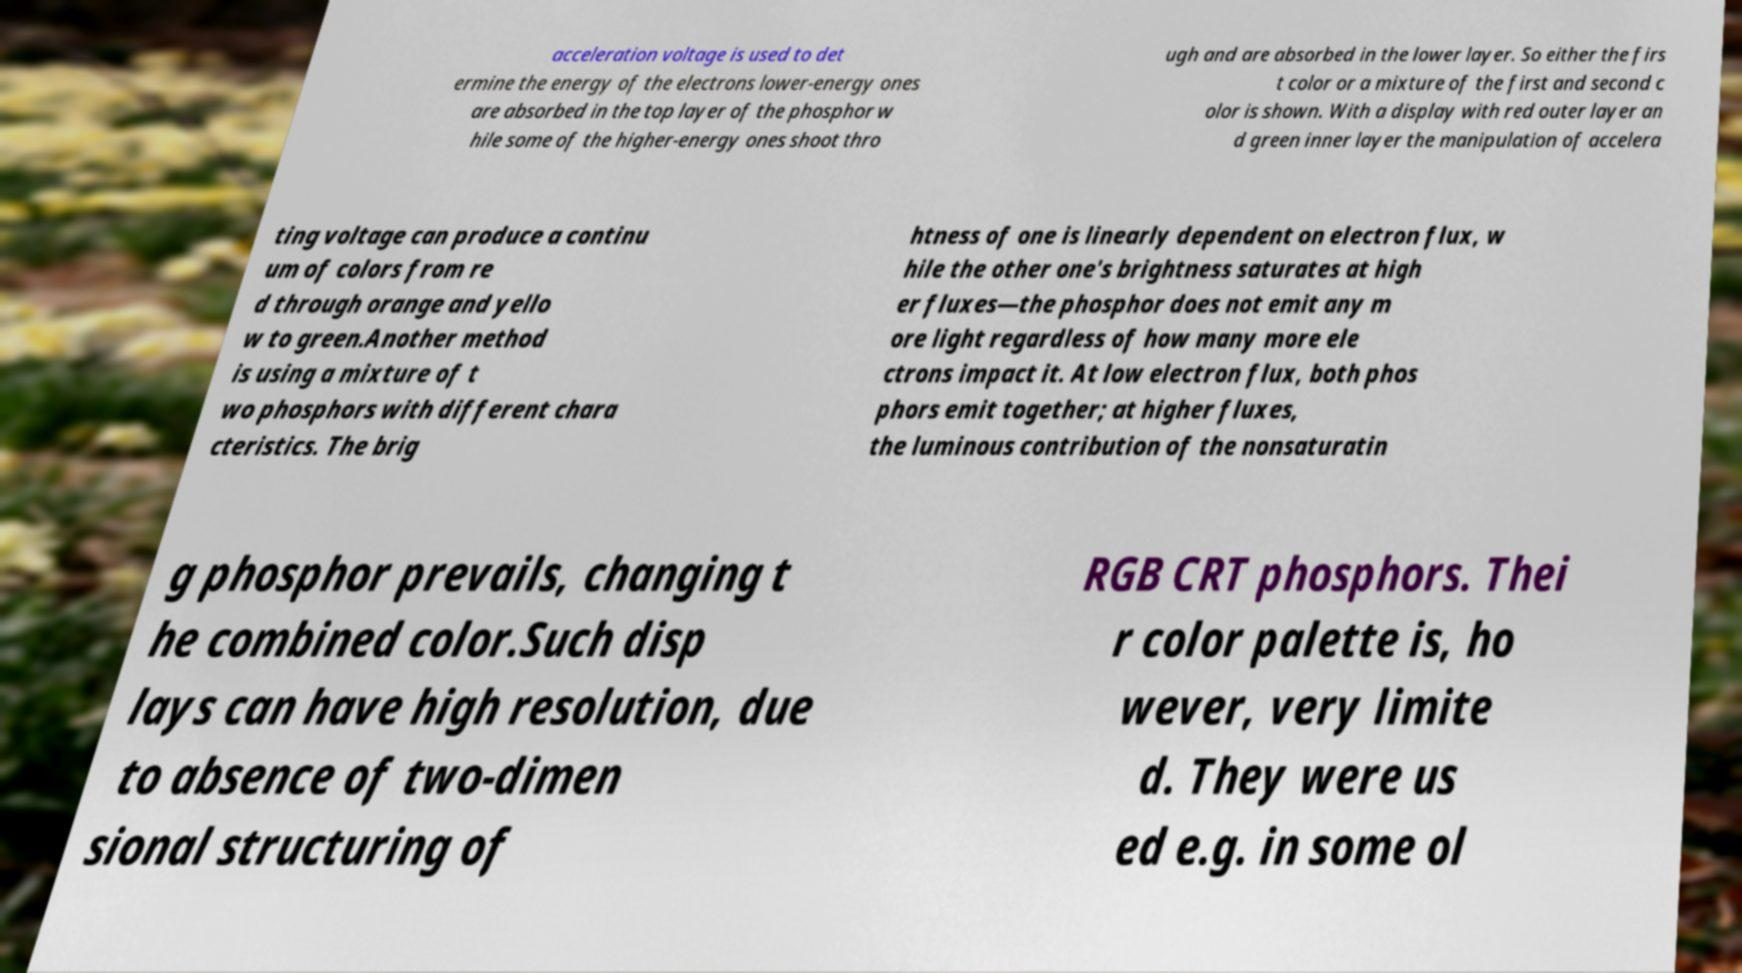Can you read and provide the text displayed in the image?This photo seems to have some interesting text. Can you extract and type it out for me? acceleration voltage is used to det ermine the energy of the electrons lower-energy ones are absorbed in the top layer of the phosphor w hile some of the higher-energy ones shoot thro ugh and are absorbed in the lower layer. So either the firs t color or a mixture of the first and second c olor is shown. With a display with red outer layer an d green inner layer the manipulation of accelera ting voltage can produce a continu um of colors from re d through orange and yello w to green.Another method is using a mixture of t wo phosphors with different chara cteristics. The brig htness of one is linearly dependent on electron flux, w hile the other one's brightness saturates at high er fluxes—the phosphor does not emit any m ore light regardless of how many more ele ctrons impact it. At low electron flux, both phos phors emit together; at higher fluxes, the luminous contribution of the nonsaturatin g phosphor prevails, changing t he combined color.Such disp lays can have high resolution, due to absence of two-dimen sional structuring of RGB CRT phosphors. Thei r color palette is, ho wever, very limite d. They were us ed e.g. in some ol 